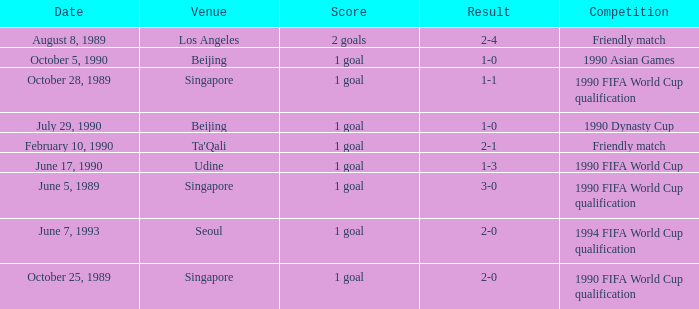What is the score of the match on October 5, 1990? 1 goal. 